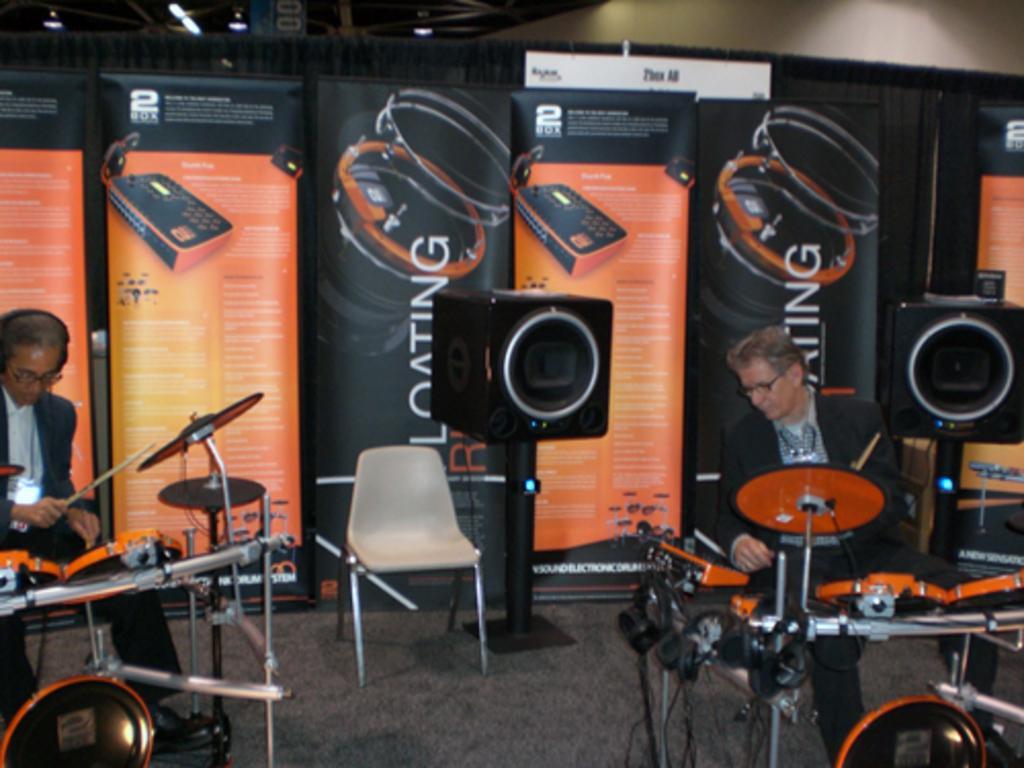In one or two sentences, can you explain what this image depicts? Two persons on the left and right are playing drums. Person on the left is wearing a specs and headphones. In the background there is chair, two speakers and a banner on the wall. 